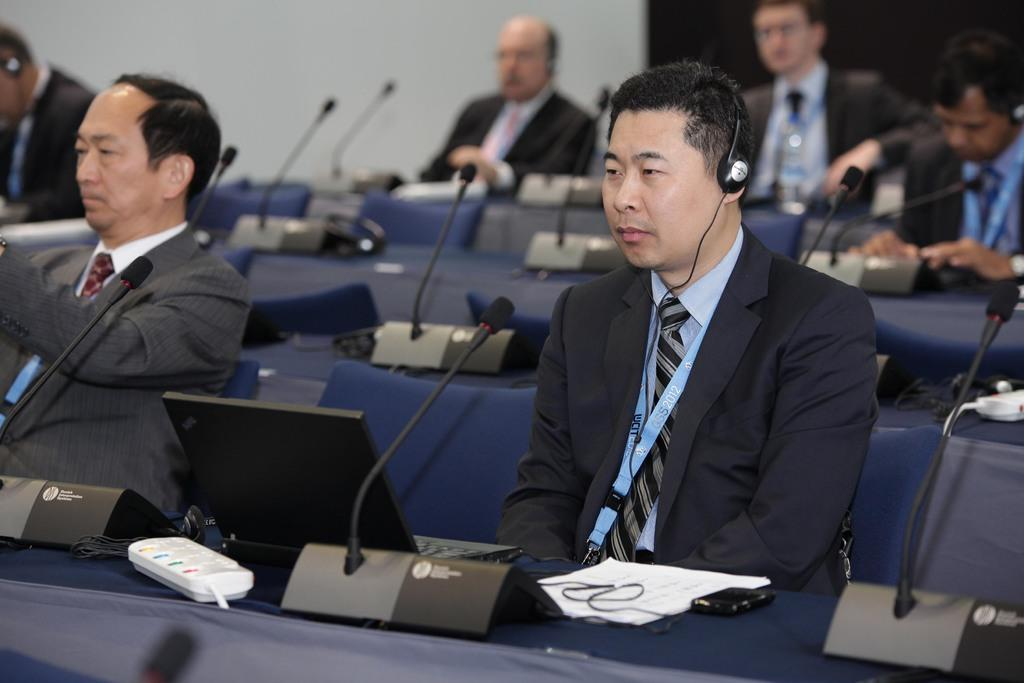What are the persons in the image wearing? The persons in the image are wearing suits. What are the persons in the image doing? The persons are sitting. What objects can be seen in the image that are used for amplifying sound? There are microphones in the image. What objects can be seen in the image that are used for hydration? There are water bottles in the image. What other items can be seen in the image? There are other items in the image, but their specific nature is not mentioned in the provided facts. What can be seen in the background of the image? There is a wall in the background of the image. What type of string is being used to attack the persons in the image? There is no string or attack present in the image; the persons are sitting and wearing suits. 